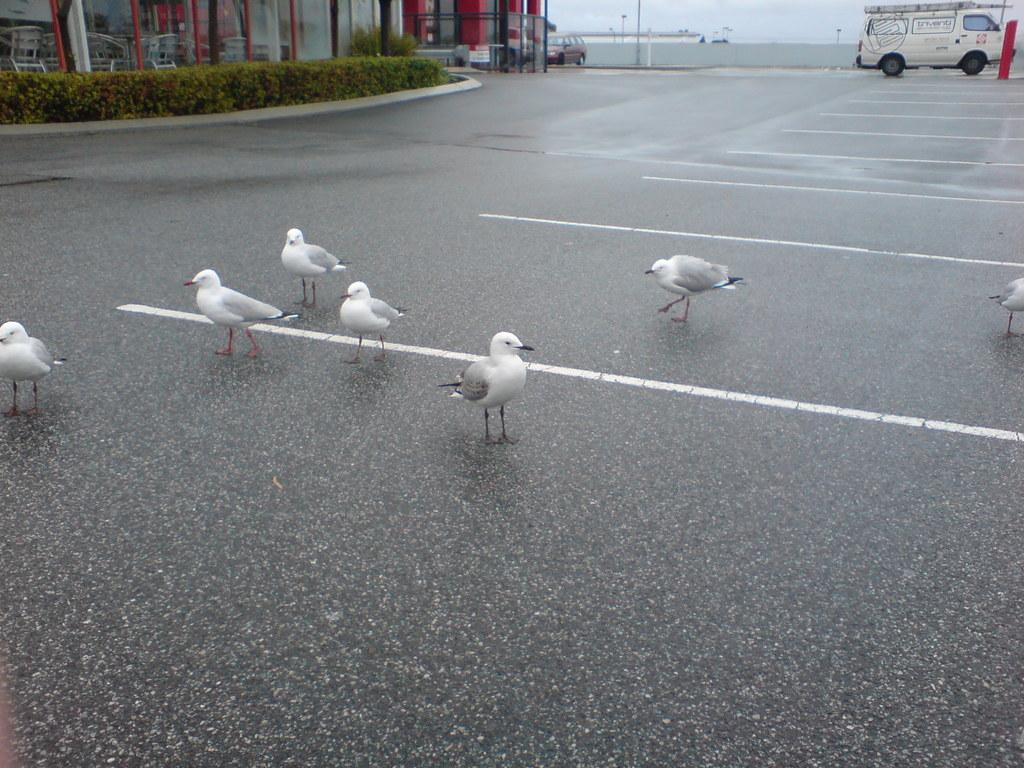What type of animals can be seen in the image? There are birds in the image. What are the birds doing in the image? The birds are walking and standing on the road. What can be seen in the top left corner of the image? There is a building in the top left corner of the image. What is present in the top right corner of the image? There are two vehicles in the top right corner of the image. What historical event is being commemorated by the birds in the image? There is no indication of a historical event or commemoration in the image; it simply shows birds walking and standing on the road. 